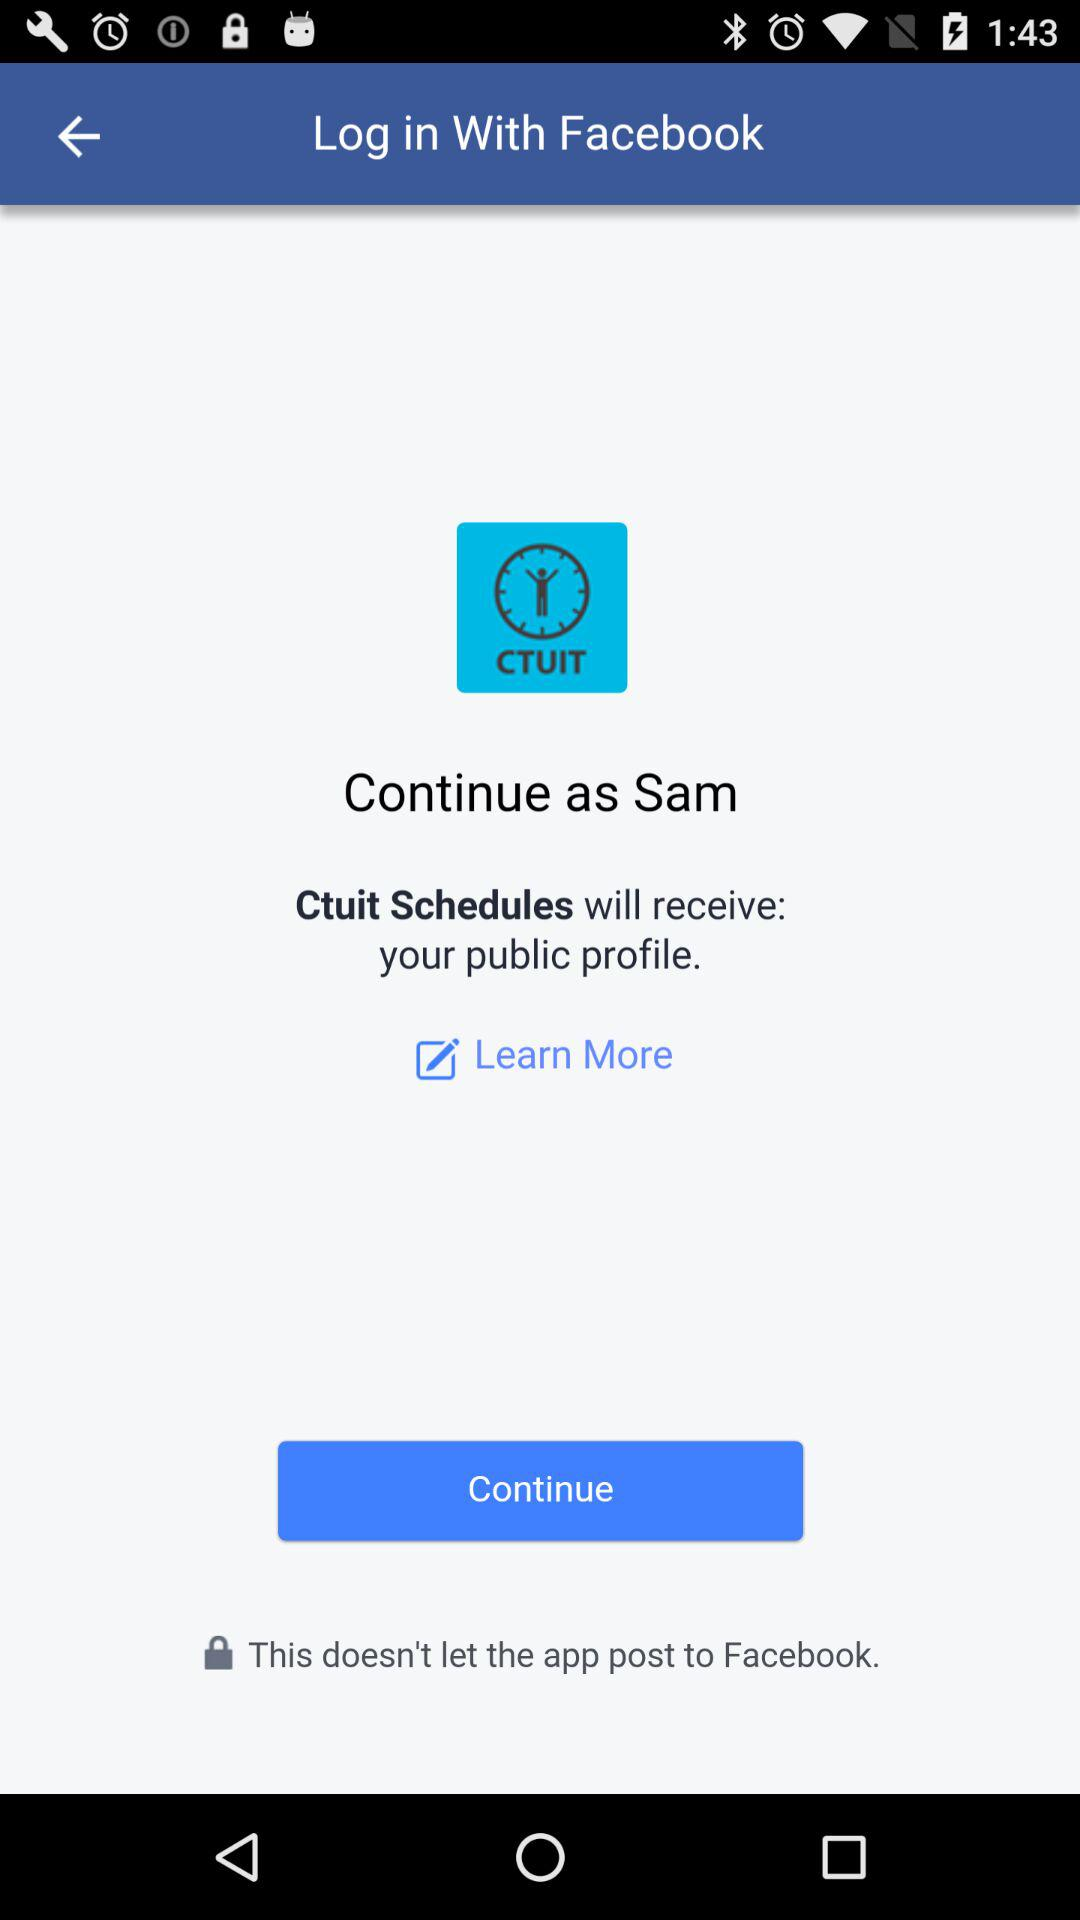What is the user name to continue on the log in page? The user name to continue on the log in page is Sam. 